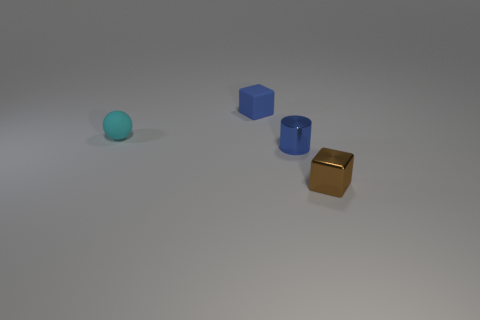What is the color of the other small thing that is made of the same material as the tiny brown object? The other small item made from a similar material as the tiny brown object is blue. It's a cube that shares the same matte finish and appears to be of a similar size, suggesting they might be part of a set designed for educational or decorative purposes. 